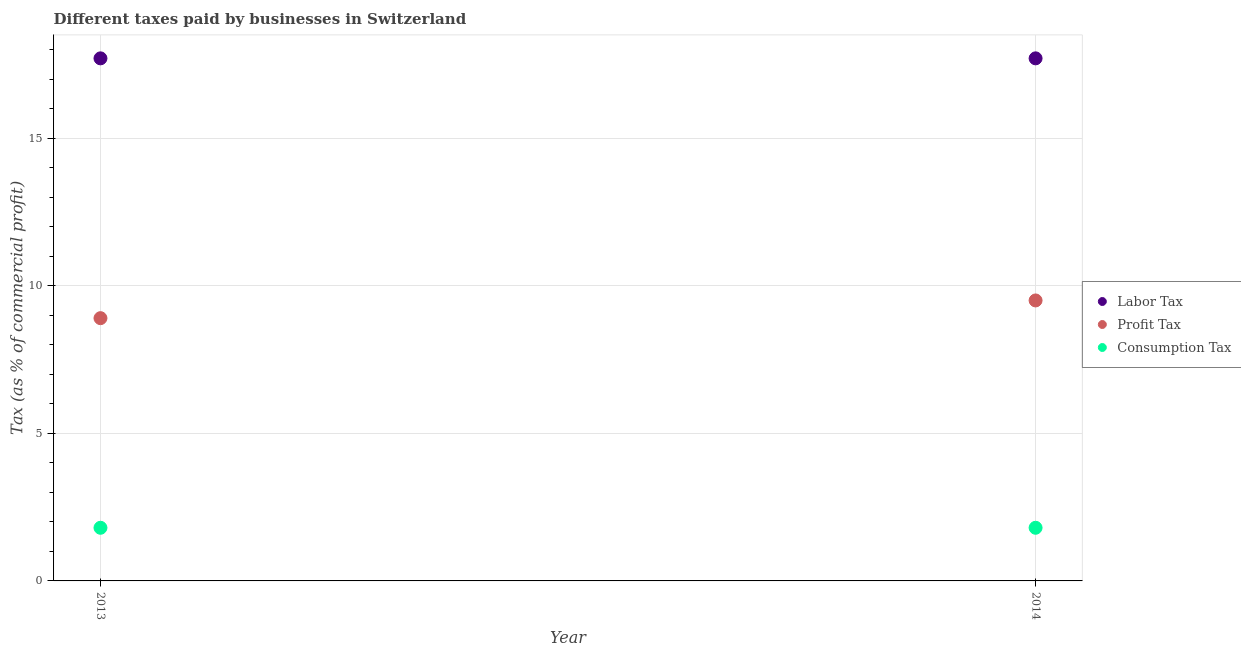Across all years, what is the maximum percentage of consumption tax?
Provide a short and direct response. 1.8. In which year was the percentage of consumption tax maximum?
Give a very brief answer. 2013. What is the difference between the percentage of profit tax in 2013 and that in 2014?
Your response must be concise. -0.6. In the year 2013, what is the difference between the percentage of profit tax and percentage of labor tax?
Your response must be concise. -8.8. In how many years, is the percentage of labor tax greater than 3 %?
Your answer should be compact. 2. What is the ratio of the percentage of consumption tax in 2013 to that in 2014?
Offer a terse response. 1. In how many years, is the percentage of consumption tax greater than the average percentage of consumption tax taken over all years?
Ensure brevity in your answer.  0. Is it the case that in every year, the sum of the percentage of labor tax and percentage of profit tax is greater than the percentage of consumption tax?
Give a very brief answer. Yes. Does the percentage of consumption tax monotonically increase over the years?
Ensure brevity in your answer.  No. Is the percentage of labor tax strictly greater than the percentage of profit tax over the years?
Offer a very short reply. Yes. Is the percentage of labor tax strictly less than the percentage of consumption tax over the years?
Provide a succinct answer. No. How many dotlines are there?
Make the answer very short. 3. What is the difference between two consecutive major ticks on the Y-axis?
Make the answer very short. 5. Are the values on the major ticks of Y-axis written in scientific E-notation?
Ensure brevity in your answer.  No. How many legend labels are there?
Give a very brief answer. 3. What is the title of the graph?
Offer a very short reply. Different taxes paid by businesses in Switzerland. What is the label or title of the X-axis?
Your answer should be very brief. Year. What is the label or title of the Y-axis?
Provide a succinct answer. Tax (as % of commercial profit). What is the Tax (as % of commercial profit) of Labor Tax in 2013?
Give a very brief answer. 17.7. What is the Tax (as % of commercial profit) in Profit Tax in 2013?
Give a very brief answer. 8.9. What is the Tax (as % of commercial profit) of Consumption Tax in 2013?
Provide a succinct answer. 1.8. What is the Tax (as % of commercial profit) of Profit Tax in 2014?
Offer a very short reply. 9.5. Across all years, what is the maximum Tax (as % of commercial profit) of Labor Tax?
Your answer should be very brief. 17.7. Across all years, what is the maximum Tax (as % of commercial profit) in Profit Tax?
Make the answer very short. 9.5. Across all years, what is the minimum Tax (as % of commercial profit) of Profit Tax?
Give a very brief answer. 8.9. Across all years, what is the minimum Tax (as % of commercial profit) of Consumption Tax?
Provide a short and direct response. 1.8. What is the total Tax (as % of commercial profit) in Labor Tax in the graph?
Give a very brief answer. 35.4. What is the total Tax (as % of commercial profit) in Consumption Tax in the graph?
Provide a short and direct response. 3.6. What is the difference between the Tax (as % of commercial profit) in Labor Tax in 2013 and that in 2014?
Provide a short and direct response. 0. What is the difference between the Tax (as % of commercial profit) of Labor Tax in 2013 and the Tax (as % of commercial profit) of Profit Tax in 2014?
Give a very brief answer. 8.2. What is the difference between the Tax (as % of commercial profit) of Labor Tax in 2013 and the Tax (as % of commercial profit) of Consumption Tax in 2014?
Provide a short and direct response. 15.9. What is the difference between the Tax (as % of commercial profit) in Profit Tax in 2013 and the Tax (as % of commercial profit) in Consumption Tax in 2014?
Provide a short and direct response. 7.1. What is the average Tax (as % of commercial profit) in Labor Tax per year?
Your answer should be very brief. 17.7. What is the average Tax (as % of commercial profit) of Profit Tax per year?
Make the answer very short. 9.2. In the year 2013, what is the difference between the Tax (as % of commercial profit) of Labor Tax and Tax (as % of commercial profit) of Profit Tax?
Your response must be concise. 8.8. In the year 2014, what is the difference between the Tax (as % of commercial profit) in Labor Tax and Tax (as % of commercial profit) in Profit Tax?
Provide a succinct answer. 8.2. In the year 2014, what is the difference between the Tax (as % of commercial profit) of Profit Tax and Tax (as % of commercial profit) of Consumption Tax?
Offer a very short reply. 7.7. What is the ratio of the Tax (as % of commercial profit) in Labor Tax in 2013 to that in 2014?
Make the answer very short. 1. What is the ratio of the Tax (as % of commercial profit) in Profit Tax in 2013 to that in 2014?
Your response must be concise. 0.94. What is the ratio of the Tax (as % of commercial profit) in Consumption Tax in 2013 to that in 2014?
Keep it short and to the point. 1. What is the difference between the highest and the second highest Tax (as % of commercial profit) of Labor Tax?
Your answer should be compact. 0. What is the difference between the highest and the second highest Tax (as % of commercial profit) of Profit Tax?
Your answer should be very brief. 0.6. What is the difference between the highest and the lowest Tax (as % of commercial profit) of Profit Tax?
Provide a short and direct response. 0.6. What is the difference between the highest and the lowest Tax (as % of commercial profit) in Consumption Tax?
Offer a terse response. 0. 